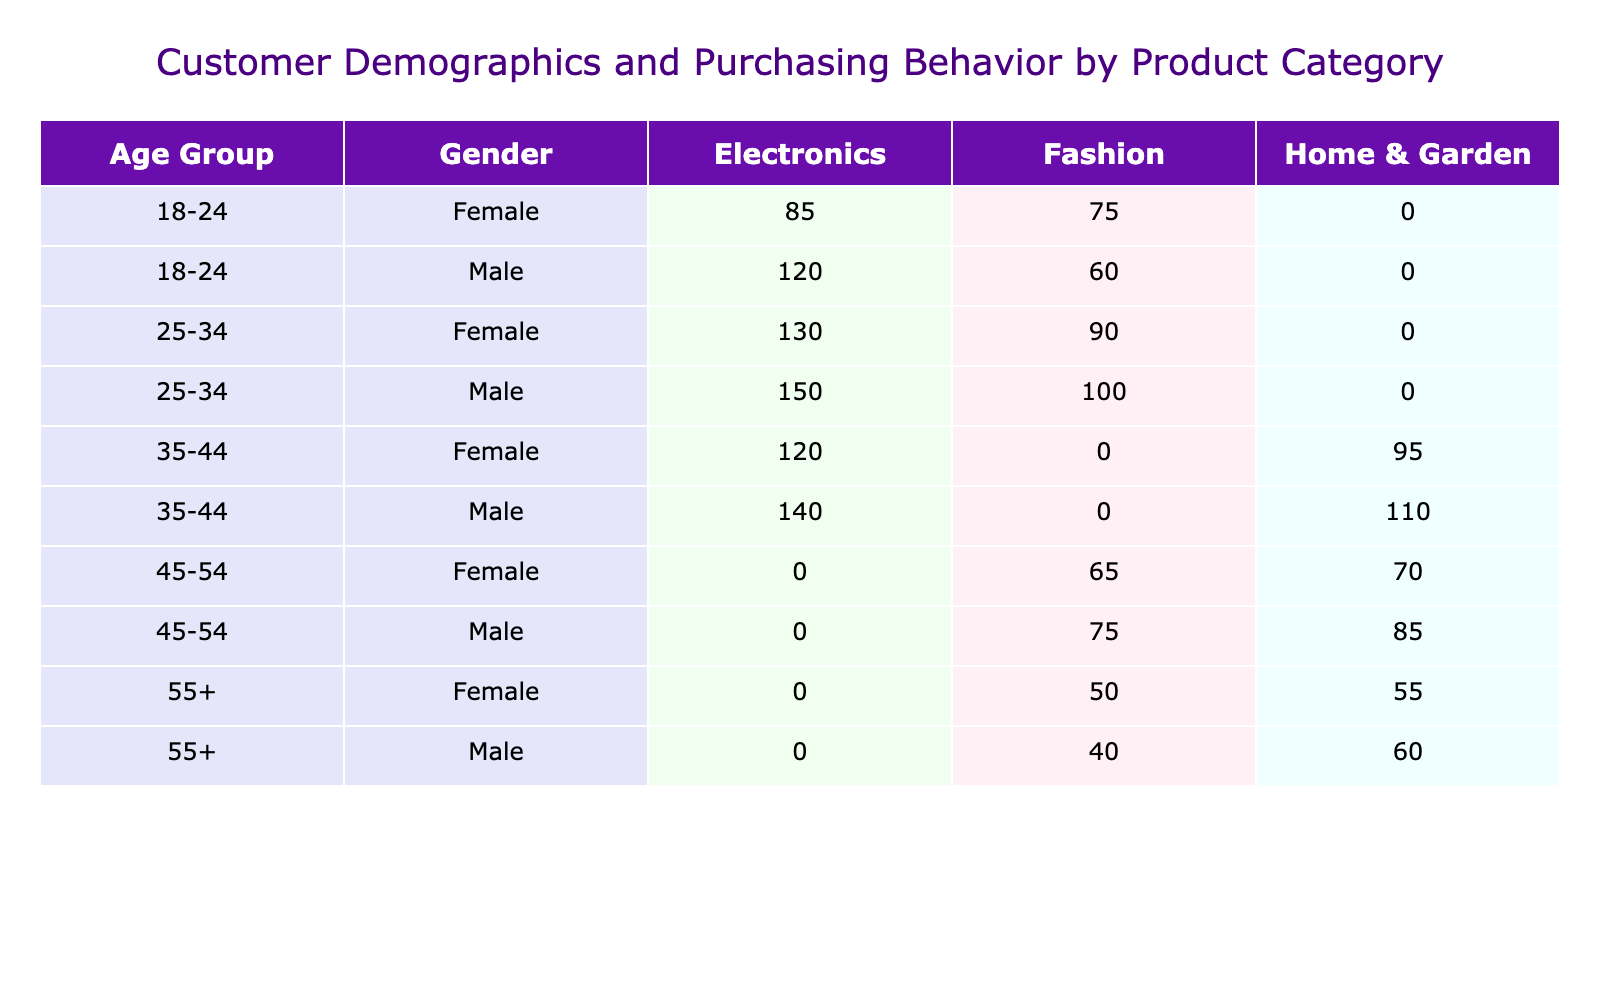What age group has the highest total purchases in Electronics? By looking at the "Electronics" column for each age group, we can total the purchases for each. The totals are: 120 + 150 + 140 = 410 for 18-24, 25-34, and 35-44 respectively. The total for 25-34 exceeds the others, so the highest total is 280 for the 25-34 age group.
Answer: 25-34 What is the total number of purchases made by Female customers in the Fashion category? We find the total purchases for Females in the Fashion category by summing the values: 75 (18-24) + 90 (25-34) + 65 (45-54) + 50 (55+) = 280.
Answer: 280 Is the total number of purchases for Male customers in Home & Garden greater than that for Female customers in the same category? We sum the Male purchases: 110 + 85 + 60 = 255, and the Female purchases: 95 + 70 + 55 = 220. Since 255 is greater than 220, the statement is true.
Answer: Yes What is the average number of purchases for Female customers across all age groups in Electronics? For Females in Electronics, we have the values: 85 (18-24), 130 (25-34), 120 (35-44), and 0 for 45-54 and 55+. The average is calculated by (85 + 130 + 120) / 3 = 111.67.
Answer: 111.67 Which product category did Male customers aged 35-44 purchase the least? Looking at the purchases for Males aged 35-44, the values are: Home & Garden (110) and Electronics (140). Since 110 is less than 140, the least purchased category is Home & Garden.
Answer: Home & Garden What is the difference in total purchases between Male and Female customers for the Fashion category? We sum the totals for Male Fashion purchases: 60 (18-24) + 100 (25-34) + 75 (45-54) + 40 (55+) = 275, and for Female Fashion: 75 + 90 + 65 + 50 = 280. The difference is 275 - 280 = -5, meaning Females purchased 5 more.
Answer: 5 What percentage of the total purchases in the Electronics category are from customers aged 18-24? Total Electronics purchases are 410 (the sums from ages 18-24, 25-34, and 35-44). The purchases from 18-24 are 120. Thus, the percentage is (120 / 410) * 100 = 29.27%.
Answer: 29.27% Who has the highest number of total purchases in any category? To find the highest number of total purchases, we need to compare the totals across all rows. The highest single amount comes from Males aged 25-34 in Electronics, which is 150.
Answer: 150 